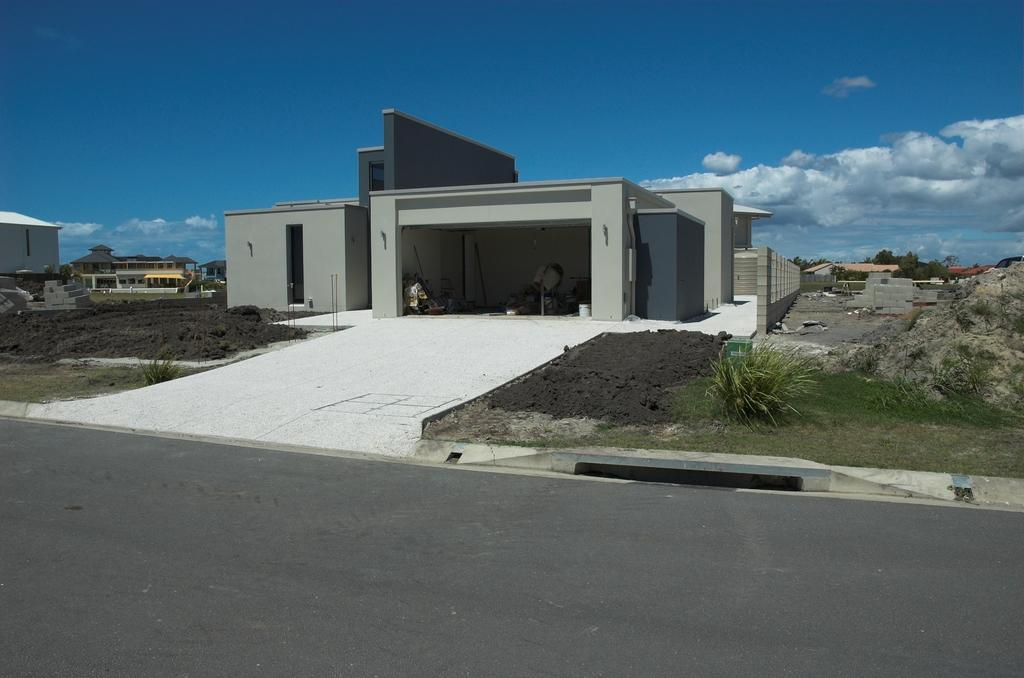What type of structures can be seen in the image? There are buildings in the image. What is the ground surface like in the image? There is mud visible in the image. What type of pathway is present in the image? There is a road in the image. What type of vegetation can be seen in the image? There are trees in the image. What is visible in the background of the image? The sky is visible in the background of the image. What can be seen in the sky in the image? There are clouds in the sky. Is there a boy experiencing pain in the image? There is no boy or indication of pain present in the image. What type of sheet is covering the trees in the image? There is no sheet covering the trees in the image; only the buildings, mud, road, trees, sky, and clouds are present. 